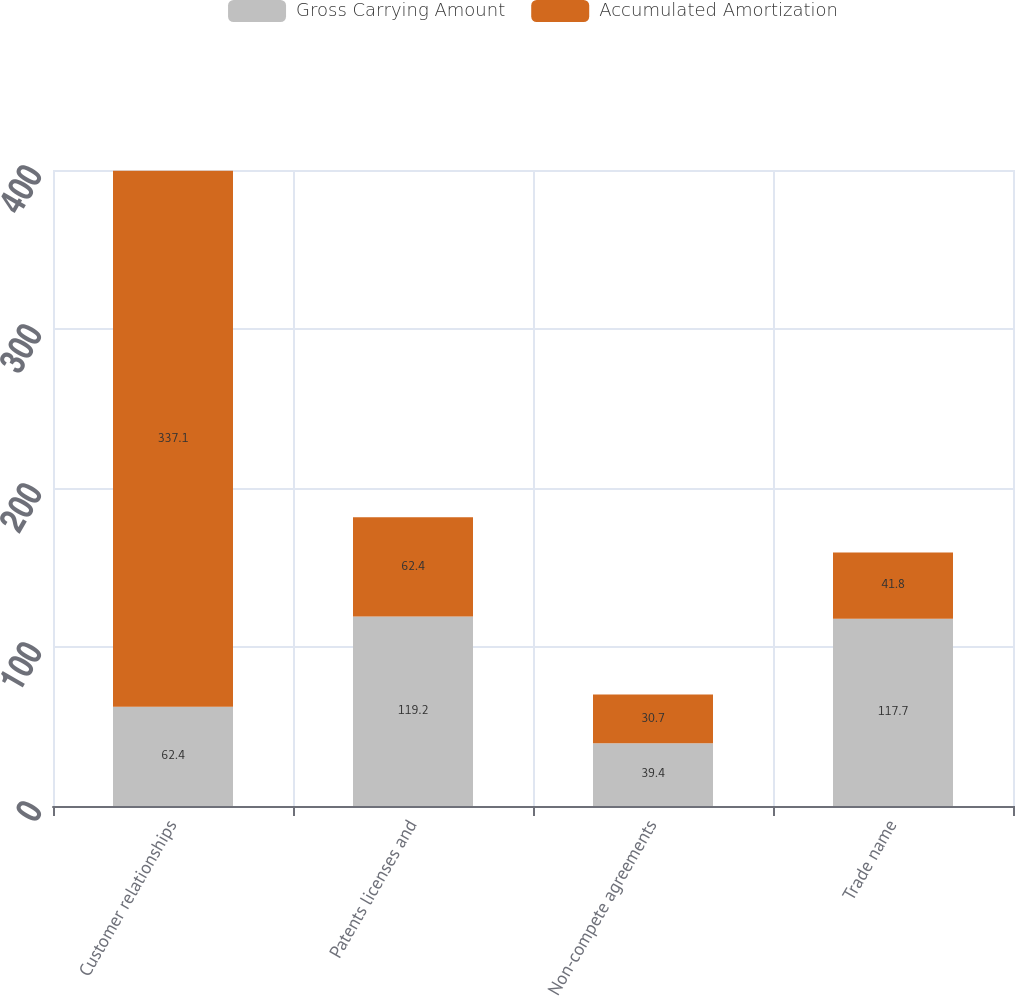<chart> <loc_0><loc_0><loc_500><loc_500><stacked_bar_chart><ecel><fcel>Customer relationships<fcel>Patents licenses and<fcel>Non-compete agreements<fcel>Trade name<nl><fcel>Gross Carrying Amount<fcel>62.4<fcel>119.2<fcel>39.4<fcel>117.7<nl><fcel>Accumulated Amortization<fcel>337.1<fcel>62.4<fcel>30.7<fcel>41.8<nl></chart> 